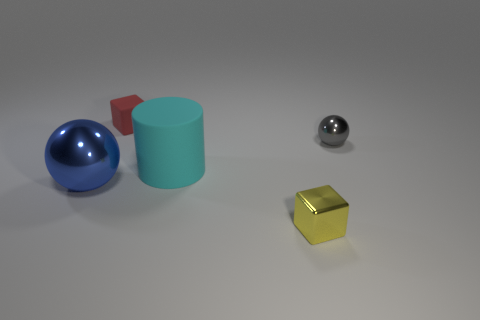Do the big cylinder and the metallic block have the same color?
Provide a short and direct response. No. What is the shape of the gray thing that is the same size as the red rubber block?
Offer a terse response. Sphere. What number of things are either matte objects on the right side of the red object or big things in front of the big cyan cylinder?
Keep it short and to the point. 2. Is the number of large matte things less than the number of objects?
Give a very brief answer. Yes. There is a red object that is the same size as the gray thing; what is its material?
Give a very brief answer. Rubber. Do the cube that is behind the tiny metallic block and the cyan matte cylinder behind the blue sphere have the same size?
Offer a terse response. No. Are there any cubes made of the same material as the large blue ball?
Your answer should be compact. Yes. What number of objects are cubes in front of the small sphere or big green metallic cylinders?
Ensure brevity in your answer.  1. Is the cube that is to the right of the cyan cylinder made of the same material as the gray ball?
Your answer should be compact. Yes. Does the small yellow object have the same shape as the small red object?
Ensure brevity in your answer.  Yes. 